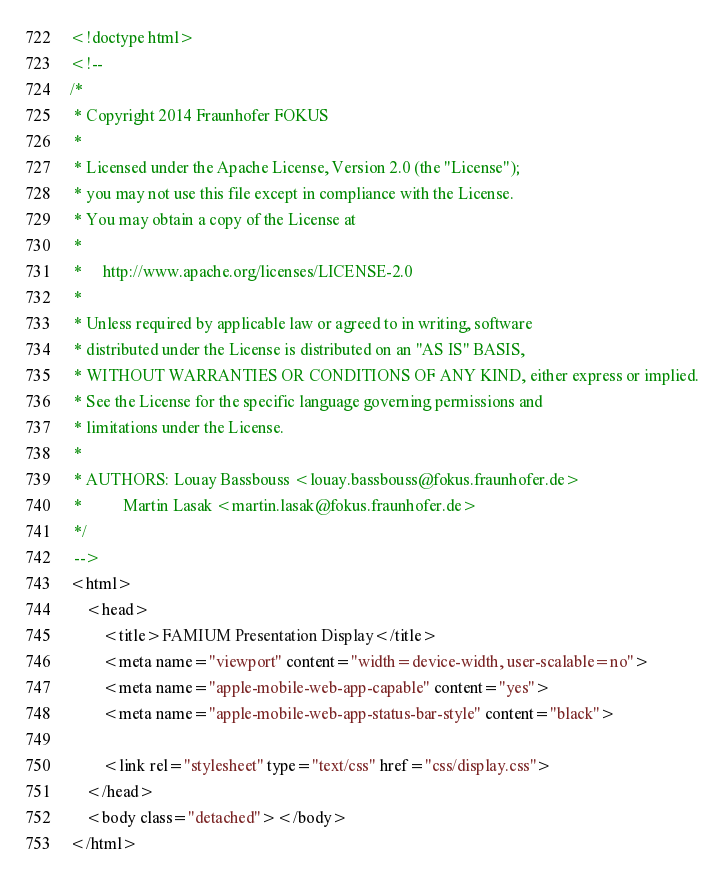Convert code to text. <code><loc_0><loc_0><loc_500><loc_500><_HTML_><!doctype html>
<!--
/*
 * Copyright 2014 Fraunhofer FOKUS
 *
 * Licensed under the Apache License, Version 2.0 (the "License");
 * you may not use this file except in compliance with the License.
 * You may obtain a copy of the License at
 *
 *     http://www.apache.org/licenses/LICENSE-2.0
 *
 * Unless required by applicable law or agreed to in writing, software
 * distributed under the License is distributed on an "AS IS" BASIS,
 * WITHOUT WARRANTIES OR CONDITIONS OF ANY KIND, either express or implied.
 * See the License for the specific language governing permissions and
 * limitations under the License.
 *
 * AUTHORS: Louay Bassbouss <louay.bassbouss@fokus.fraunhofer.de>
 *          Martin Lasak <martin.lasak@fokus.fraunhofer.de>
 */
 -->
<html>
    <head>
        <title>FAMIUM Presentation Display</title>
        <meta name="viewport" content="width=device-width, user-scalable=no">
        <meta name="apple-mobile-web-app-capable" content="yes">
        <meta name="apple-mobile-web-app-status-bar-style" content="black">

        <link rel="stylesheet" type="text/css" href="css/display.css">
    </head>
    <body class="detached"></body>
</html>
</code> 